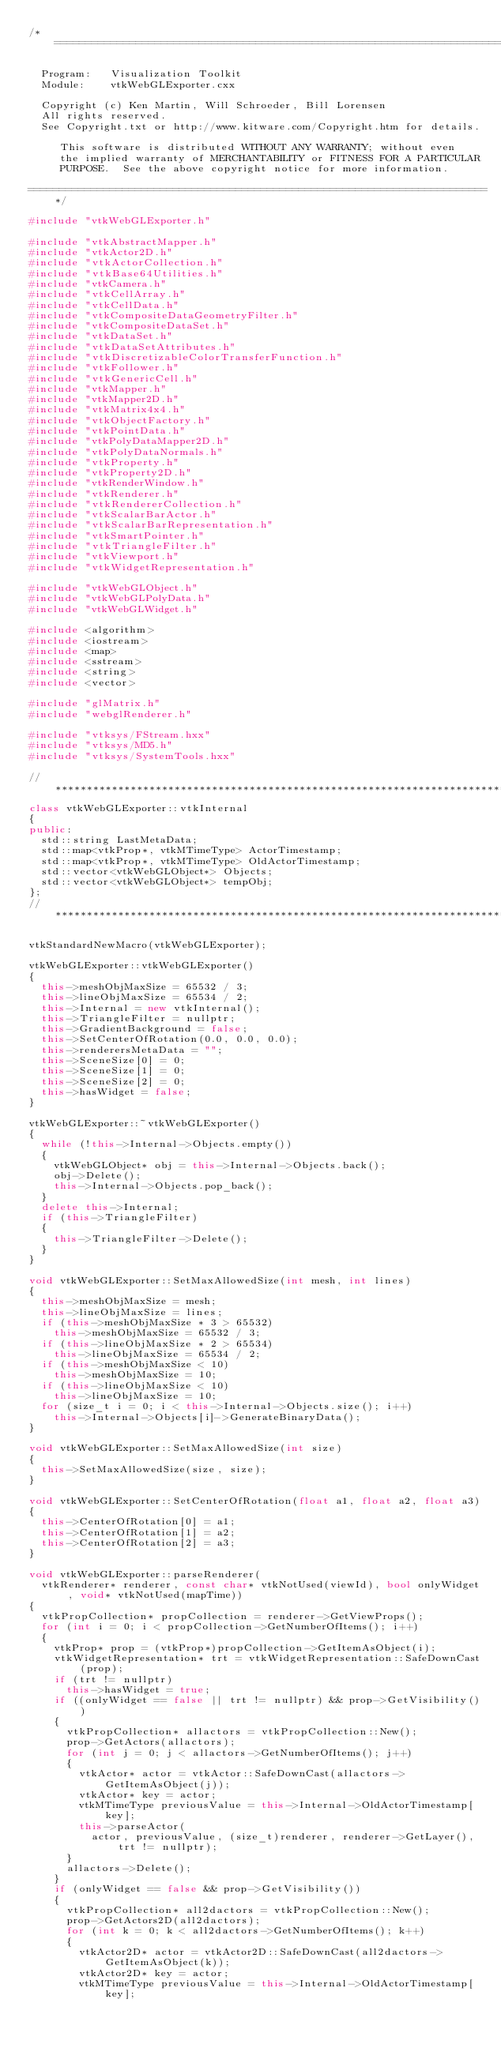Convert code to text. <code><loc_0><loc_0><loc_500><loc_500><_C++_>/*=========================================================================

  Program:   Visualization Toolkit
  Module:    vtkWebGLExporter.cxx

  Copyright (c) Ken Martin, Will Schroeder, Bill Lorensen
  All rights reserved.
  See Copyright.txt or http://www.kitware.com/Copyright.htm for details.

     This software is distributed WITHOUT ANY WARRANTY; without even
     the implied warranty of MERCHANTABILITY or FITNESS FOR A PARTICULAR
     PURPOSE.  See the above copyright notice for more information.

=========================================================================*/

#include "vtkWebGLExporter.h"

#include "vtkAbstractMapper.h"
#include "vtkActor2D.h"
#include "vtkActorCollection.h"
#include "vtkBase64Utilities.h"
#include "vtkCamera.h"
#include "vtkCellArray.h"
#include "vtkCellData.h"
#include "vtkCompositeDataGeometryFilter.h"
#include "vtkCompositeDataSet.h"
#include "vtkDataSet.h"
#include "vtkDataSetAttributes.h"
#include "vtkDiscretizableColorTransferFunction.h"
#include "vtkFollower.h"
#include "vtkGenericCell.h"
#include "vtkMapper.h"
#include "vtkMapper2D.h"
#include "vtkMatrix4x4.h"
#include "vtkObjectFactory.h"
#include "vtkPointData.h"
#include "vtkPolyDataMapper2D.h"
#include "vtkPolyDataNormals.h"
#include "vtkProperty.h"
#include "vtkProperty2D.h"
#include "vtkRenderWindow.h"
#include "vtkRenderer.h"
#include "vtkRendererCollection.h"
#include "vtkScalarBarActor.h"
#include "vtkScalarBarRepresentation.h"
#include "vtkSmartPointer.h"
#include "vtkTriangleFilter.h"
#include "vtkViewport.h"
#include "vtkWidgetRepresentation.h"

#include "vtkWebGLObject.h"
#include "vtkWebGLPolyData.h"
#include "vtkWebGLWidget.h"

#include <algorithm>
#include <iostream>
#include <map>
#include <sstream>
#include <string>
#include <vector>

#include "glMatrix.h"
#include "webglRenderer.h"

#include "vtksys/FStream.hxx"
#include "vtksys/MD5.h"
#include "vtksys/SystemTools.hxx"

//*****************************************************************************
class vtkWebGLExporter::vtkInternal
{
public:
  std::string LastMetaData;
  std::map<vtkProp*, vtkMTimeType> ActorTimestamp;
  std::map<vtkProp*, vtkMTimeType> OldActorTimestamp;
  std::vector<vtkWebGLObject*> Objects;
  std::vector<vtkWebGLObject*> tempObj;
};
//*****************************************************************************

vtkStandardNewMacro(vtkWebGLExporter);

vtkWebGLExporter::vtkWebGLExporter()
{
  this->meshObjMaxSize = 65532 / 3;
  this->lineObjMaxSize = 65534 / 2;
  this->Internal = new vtkInternal();
  this->TriangleFilter = nullptr;
  this->GradientBackground = false;
  this->SetCenterOfRotation(0.0, 0.0, 0.0);
  this->renderersMetaData = "";
  this->SceneSize[0] = 0;
  this->SceneSize[1] = 0;
  this->SceneSize[2] = 0;
  this->hasWidget = false;
}

vtkWebGLExporter::~vtkWebGLExporter()
{
  while (!this->Internal->Objects.empty())
  {
    vtkWebGLObject* obj = this->Internal->Objects.back();
    obj->Delete();
    this->Internal->Objects.pop_back();
  }
  delete this->Internal;
  if (this->TriangleFilter)
  {
    this->TriangleFilter->Delete();
  }
}

void vtkWebGLExporter::SetMaxAllowedSize(int mesh, int lines)
{
  this->meshObjMaxSize = mesh;
  this->lineObjMaxSize = lines;
  if (this->meshObjMaxSize * 3 > 65532)
    this->meshObjMaxSize = 65532 / 3;
  if (this->lineObjMaxSize * 2 > 65534)
    this->lineObjMaxSize = 65534 / 2;
  if (this->meshObjMaxSize < 10)
    this->meshObjMaxSize = 10;
  if (this->lineObjMaxSize < 10)
    this->lineObjMaxSize = 10;
  for (size_t i = 0; i < this->Internal->Objects.size(); i++)
    this->Internal->Objects[i]->GenerateBinaryData();
}

void vtkWebGLExporter::SetMaxAllowedSize(int size)
{
  this->SetMaxAllowedSize(size, size);
}

void vtkWebGLExporter::SetCenterOfRotation(float a1, float a2, float a3)
{
  this->CenterOfRotation[0] = a1;
  this->CenterOfRotation[1] = a2;
  this->CenterOfRotation[2] = a3;
}

void vtkWebGLExporter::parseRenderer(
  vtkRenderer* renderer, const char* vtkNotUsed(viewId), bool onlyWidget, void* vtkNotUsed(mapTime))
{
  vtkPropCollection* propCollection = renderer->GetViewProps();
  for (int i = 0; i < propCollection->GetNumberOfItems(); i++)
  {
    vtkProp* prop = (vtkProp*)propCollection->GetItemAsObject(i);
    vtkWidgetRepresentation* trt = vtkWidgetRepresentation::SafeDownCast(prop);
    if (trt != nullptr)
      this->hasWidget = true;
    if ((onlyWidget == false || trt != nullptr) && prop->GetVisibility())
    {
      vtkPropCollection* allactors = vtkPropCollection::New();
      prop->GetActors(allactors);
      for (int j = 0; j < allactors->GetNumberOfItems(); j++)
      {
        vtkActor* actor = vtkActor::SafeDownCast(allactors->GetItemAsObject(j));
        vtkActor* key = actor;
        vtkMTimeType previousValue = this->Internal->OldActorTimestamp[key];
        this->parseActor(
          actor, previousValue, (size_t)renderer, renderer->GetLayer(), trt != nullptr);
      }
      allactors->Delete();
    }
    if (onlyWidget == false && prop->GetVisibility())
    {
      vtkPropCollection* all2dactors = vtkPropCollection::New();
      prop->GetActors2D(all2dactors);
      for (int k = 0; k < all2dactors->GetNumberOfItems(); k++)
      {
        vtkActor2D* actor = vtkActor2D::SafeDownCast(all2dactors->GetItemAsObject(k));
        vtkActor2D* key = actor;
        vtkMTimeType previousValue = this->Internal->OldActorTimestamp[key];</code> 